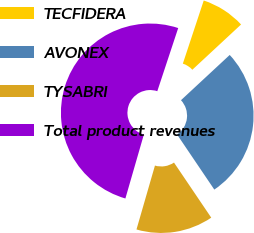<chart> <loc_0><loc_0><loc_500><loc_500><pie_chart><fcel>TECFIDERA<fcel>AVONEX<fcel>TYSABRI<fcel>Total product revenues<nl><fcel>8.0%<fcel>27.45%<fcel>13.94%<fcel>50.61%<nl></chart> 